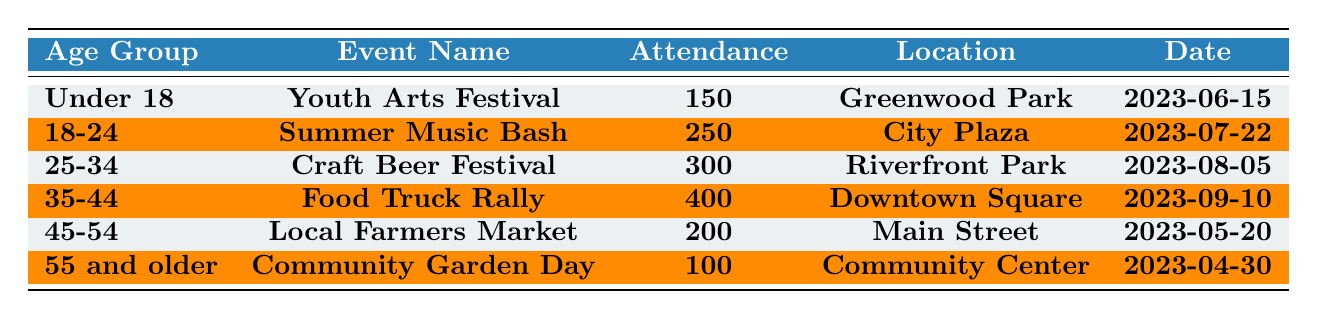What is the event with the highest attendance? By looking at the attendance values in the table, we can see that the "Food Truck Rally" has 400 attendees, which is the largest number compared to other events.
Answer: Food Truck Rally How many attendees were there at the "Community Garden Day"? The table shows that the "Community Garden Day" had an attendance of 100 people, as indicated in the attendance column.
Answer: 100 Is the attendance for the "Local Farmers Market" greater than that for the "Youth Arts Festival"? The attendance for the "Local Farmers Market" is 200, while the "Youth Arts Festival" had 150 attendees, therefore 200 > 150 is true.
Answer: Yes What is the total attendance for all events? Adding the attendance numbers: 150 + 250 + 300 + 400 + 200 + 100 = 1400. This gives us the total attendance across all events listed in the table.
Answer: 1400 Which age group had the lowest attendance at their event? Looking through the attendance values, we see that the "Community Garden Day" for the age group "55 and older" had the lowest attendance with 100 people.
Answer: 55 and older What is the difference in attendance between the "Craft Beer Festival" and the "Summer Music Bash"? The attendance for the "Craft Beer Festival" is 300, while for the "Summer Music Bash," it is 250. So the difference is 300 - 250 = 50.
Answer: 50 What age group attended more events, those "35-44" or "25-34"? Both age groups attended only one event each in the table, therefore neither age group attended more events than the other.
Answer: Neither What is the average attendance for events targeted at the "Under 18" and "55 and older" age groups? The attendance for "Under 18" is 150 and for "55 and older" it is 100. To find the average, we calculate (150 + 100) / 2 = 125.
Answer: 125 Which event occurred last in terms of date? Checking the dates, the "Food Truck Rally" is dated 2023-09-10, which is later than all other events listed in the table.
Answer: Food Truck Rally Is the attendance for the "Summer Music Bash" equal to the attendance for the "Local Farmers Market"? The "Summer Music Bash" had 250 attendees while the "Local Farmers Market" had 200, thus they are not equal, making the statement false.
Answer: No 